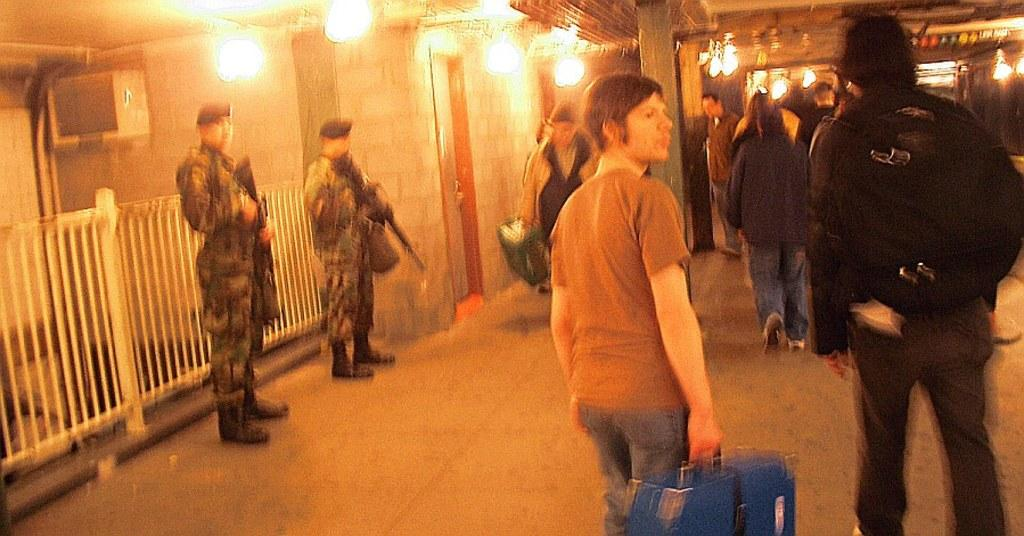What are the persons in the image doing? The persons in the image are walking. Are there any objects or items being held by the persons? Yes, two persons are holding a gun. What can be seen hanging from the roof in the image? There are lights hanged from the roof in the image. Can you see a tramp performing tricks in the image? No, there is no tramp performing tricks in the image. What type of fog is present in the image? There is no fog present in the image. 